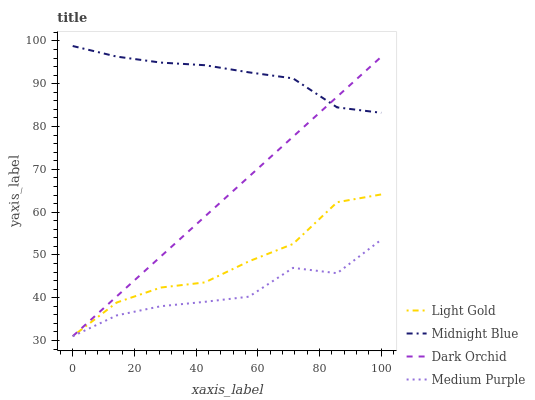Does Medium Purple have the minimum area under the curve?
Answer yes or no. Yes. Does Midnight Blue have the maximum area under the curve?
Answer yes or no. Yes. Does Light Gold have the minimum area under the curve?
Answer yes or no. No. Does Light Gold have the maximum area under the curve?
Answer yes or no. No. Is Dark Orchid the smoothest?
Answer yes or no. Yes. Is Medium Purple the roughest?
Answer yes or no. Yes. Is Light Gold the smoothest?
Answer yes or no. No. Is Light Gold the roughest?
Answer yes or no. No. Does Medium Purple have the lowest value?
Answer yes or no. Yes. Does Midnight Blue have the lowest value?
Answer yes or no. No. Does Midnight Blue have the highest value?
Answer yes or no. Yes. Does Light Gold have the highest value?
Answer yes or no. No. Is Medium Purple less than Midnight Blue?
Answer yes or no. Yes. Is Midnight Blue greater than Medium Purple?
Answer yes or no. Yes. Does Midnight Blue intersect Dark Orchid?
Answer yes or no. Yes. Is Midnight Blue less than Dark Orchid?
Answer yes or no. No. Is Midnight Blue greater than Dark Orchid?
Answer yes or no. No. Does Medium Purple intersect Midnight Blue?
Answer yes or no. No. 